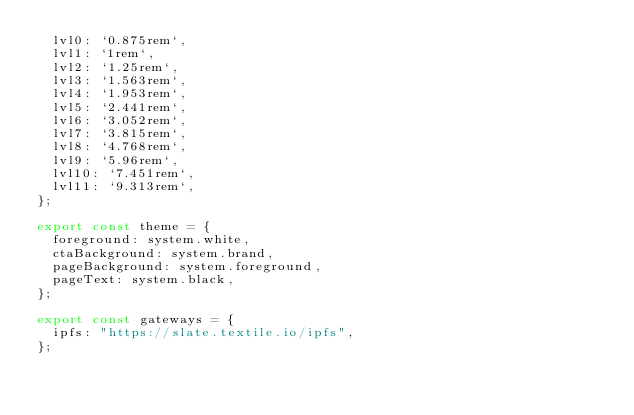Convert code to text. <code><loc_0><loc_0><loc_500><loc_500><_JavaScript_>  lvl0: `0.875rem`,
  lvl1: `1rem`,
  lvl2: `1.25rem`,
  lvl3: `1.563rem`,
  lvl4: `1.953rem`,
  lvl5: `2.441rem`,
  lvl6: `3.052rem`,
  lvl7: `3.815rem`,
  lvl8: `4.768rem`,
  lvl9: `5.96rem`,
  lvl10: `7.451rem`,
  lvl11: `9.313rem`,
};

export const theme = {
  foreground: system.white,
  ctaBackground: system.brand,
  pageBackground: system.foreground,
  pageText: system.black,
};

export const gateways = {
  ipfs: "https://slate.textile.io/ipfs",
};
</code> 